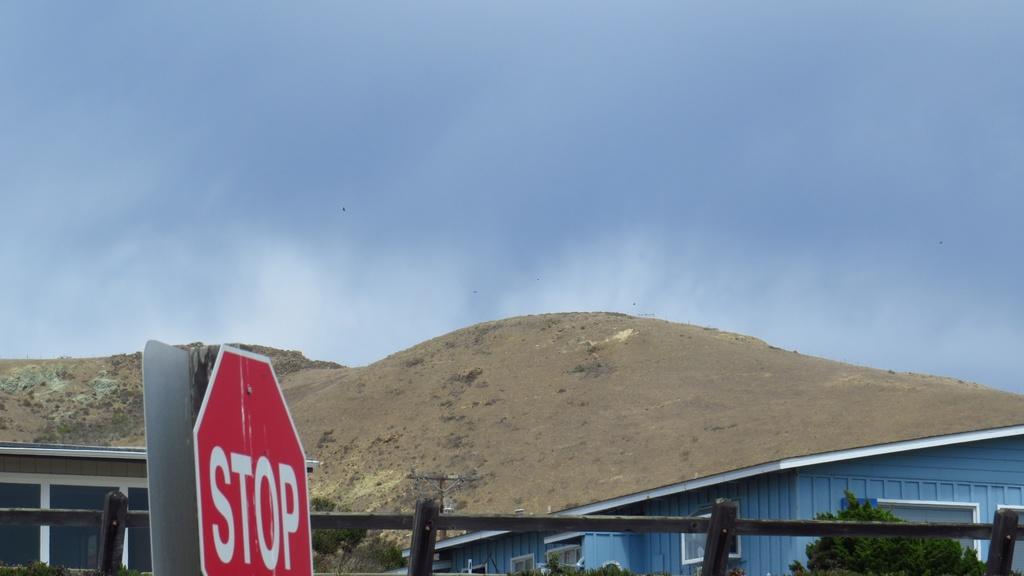What does the sign say?
Keep it short and to the point. Stop. Is this a yield sign?
Ensure brevity in your answer.  No. 